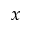Convert formula to latex. <formula><loc_0><loc_0><loc_500><loc_500>x</formula> 